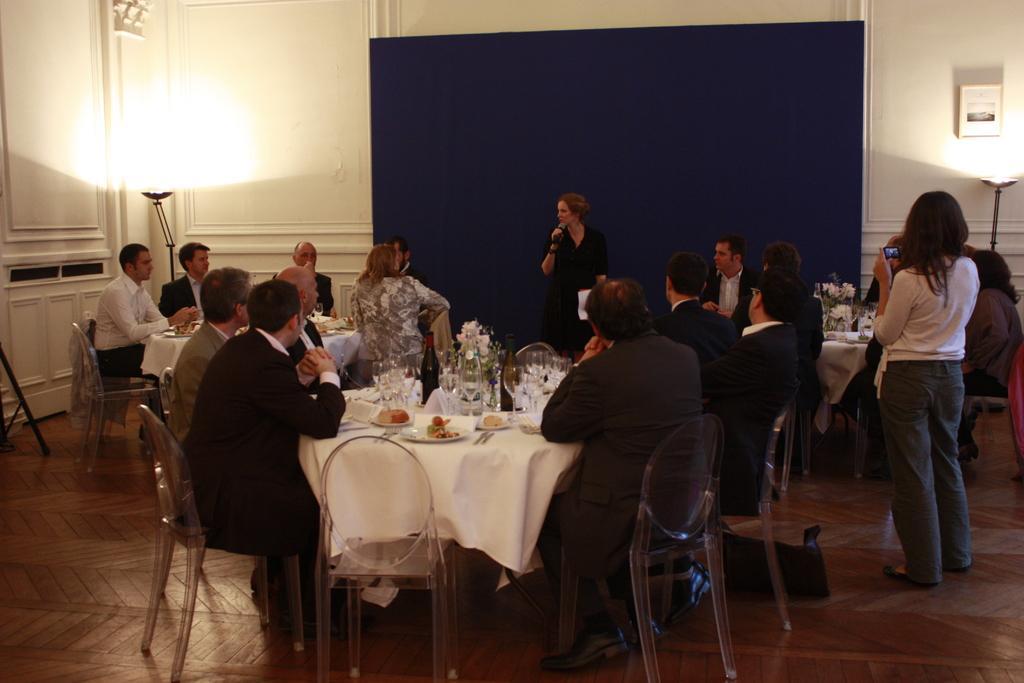Could you give a brief overview of what you see in this image? There are some people sitting in the chairs around the tables on which some food items and tissue papers were placed. There is a woman standing in front of a blue colored cloth and holding a mic. In the background there is a wall and a light here. 